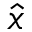<formula> <loc_0><loc_0><loc_500><loc_500>\hat { x }</formula> 